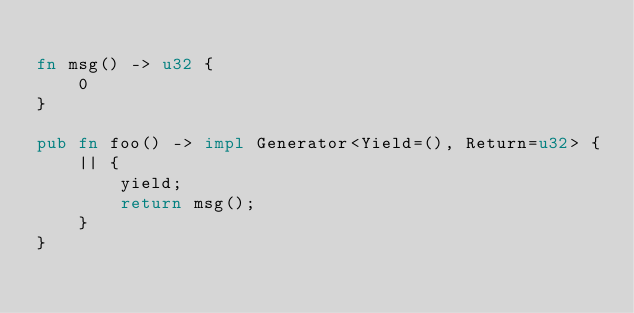<code> <loc_0><loc_0><loc_500><loc_500><_Rust_>
fn msg() -> u32 {
    0
}

pub fn foo() -> impl Generator<Yield=(), Return=u32> {
    || {
        yield;
        return msg();
    }
}
</code> 